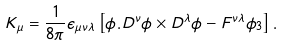<formula> <loc_0><loc_0><loc_500><loc_500>K _ { \mu } = \frac { 1 } { 8 \pi } \epsilon _ { \mu \nu \lambda } \left [ \phi . D ^ { \nu } \phi \times D ^ { \lambda } \phi - F ^ { \nu \lambda } \phi _ { 3 } \right ] .</formula> 